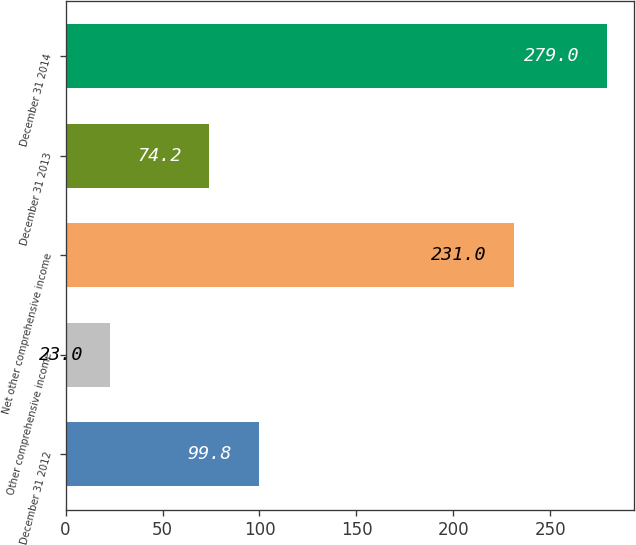Convert chart. <chart><loc_0><loc_0><loc_500><loc_500><bar_chart><fcel>December 31 2012<fcel>Other comprehensive income<fcel>Net other comprehensive income<fcel>December 31 2013<fcel>December 31 2014<nl><fcel>99.8<fcel>23<fcel>231<fcel>74.2<fcel>279<nl></chart> 